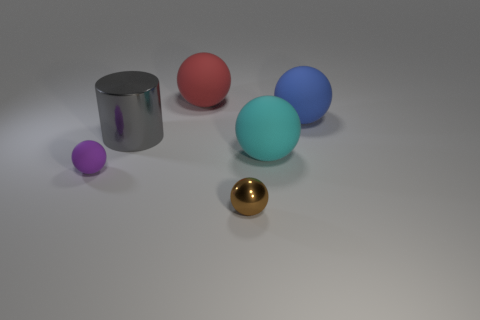How many other things are there of the same color as the small matte thing?
Offer a terse response. 0. What number of things are rubber spheres that are in front of the gray shiny cylinder or large cyan objects?
Make the answer very short. 2. There is a sphere in front of the small purple matte sphere that is in front of the cyan object; what size is it?
Keep it short and to the point. Small. What number of things are either large cylinders or objects to the right of the cyan thing?
Your answer should be very brief. 2. There is a big thing that is behind the blue rubber object; is its shape the same as the large gray thing?
Your answer should be compact. No. There is a small thing that is to the right of the big object that is on the left side of the red sphere; how many matte objects are behind it?
Your answer should be very brief. 4. Are there any other things that have the same shape as the large metal object?
Ensure brevity in your answer.  No. How many things are either small cyan cubes or tiny objects?
Keep it short and to the point. 2. Does the blue thing have the same shape as the tiny object that is to the left of the red sphere?
Provide a short and direct response. Yes. What shape is the big rubber thing in front of the big gray cylinder?
Keep it short and to the point. Sphere. 